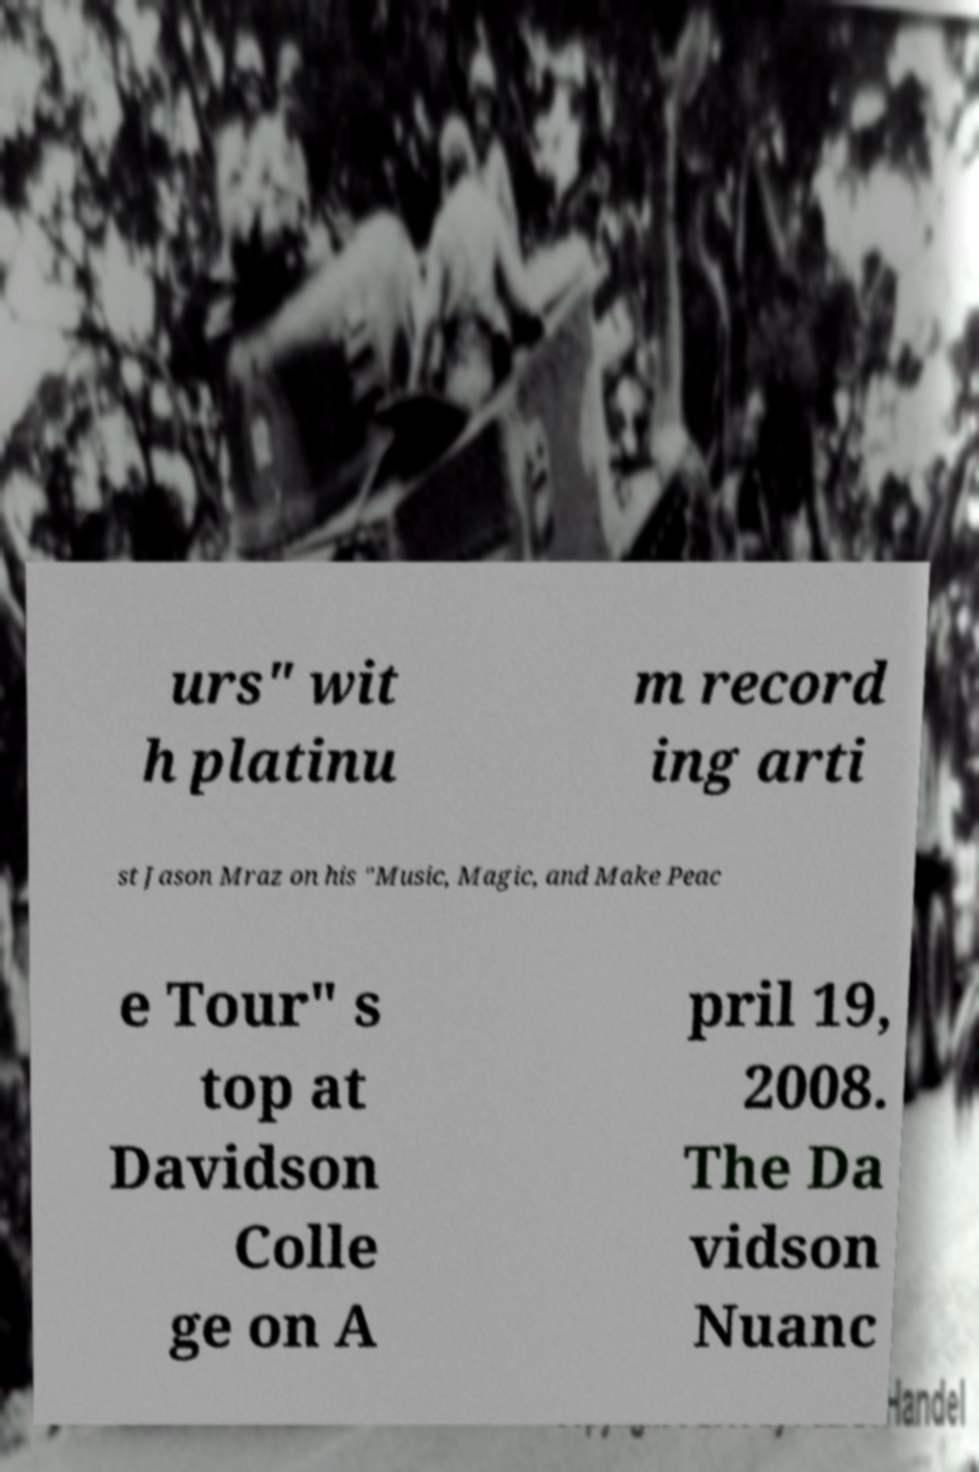Please read and relay the text visible in this image. What does it say? urs" wit h platinu m record ing arti st Jason Mraz on his "Music, Magic, and Make Peac e Tour" s top at Davidson Colle ge on A pril 19, 2008. The Da vidson Nuanc 